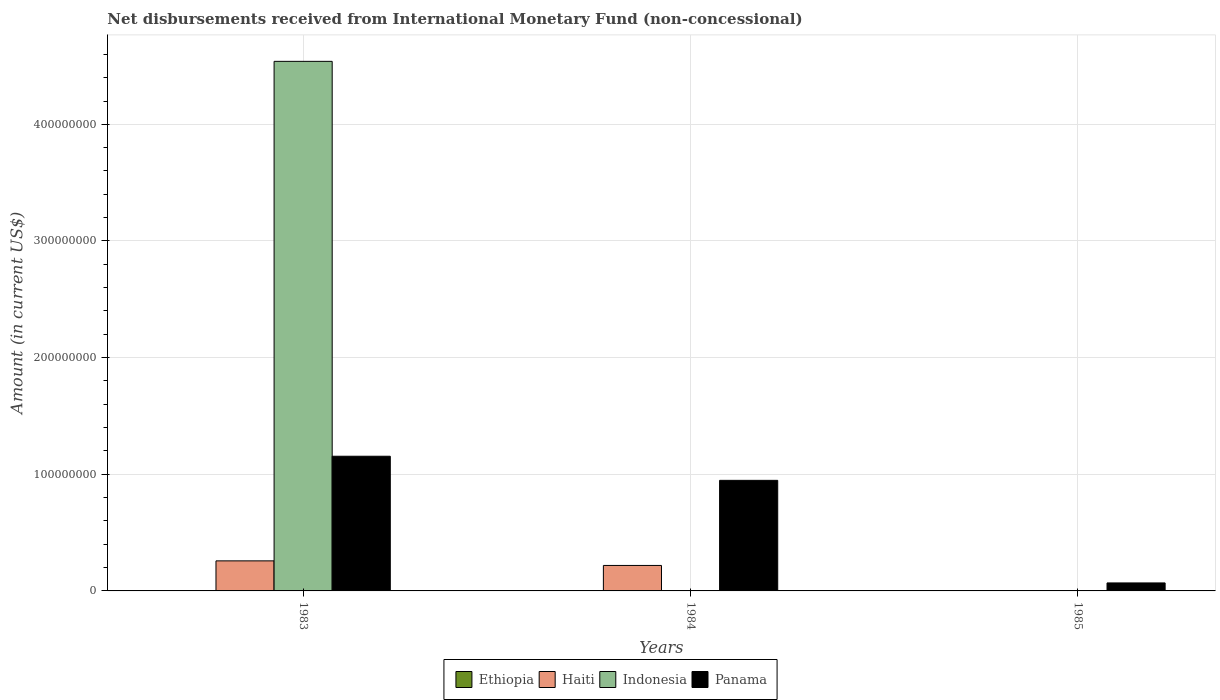What is the label of the 1st group of bars from the left?
Provide a short and direct response. 1983. In how many cases, is the number of bars for a given year not equal to the number of legend labels?
Make the answer very short. 3. What is the amount of disbursements received from International Monetary Fund in Panama in 1985?
Your answer should be very brief. 6.85e+06. Across all years, what is the maximum amount of disbursements received from International Monetary Fund in Indonesia?
Make the answer very short. 4.54e+08. Across all years, what is the minimum amount of disbursements received from International Monetary Fund in Panama?
Keep it short and to the point. 6.85e+06. In which year was the amount of disbursements received from International Monetary Fund in Haiti maximum?
Provide a short and direct response. 1983. What is the total amount of disbursements received from International Monetary Fund in Indonesia in the graph?
Provide a short and direct response. 4.54e+08. What is the difference between the amount of disbursements received from International Monetary Fund in Panama in 1983 and that in 1984?
Offer a very short reply. 2.07e+07. What is the difference between the amount of disbursements received from International Monetary Fund in Panama in 1983 and the amount of disbursements received from International Monetary Fund in Haiti in 1985?
Give a very brief answer. 1.15e+08. What is the average amount of disbursements received from International Monetary Fund in Haiti per year?
Provide a short and direct response. 1.59e+07. In the year 1983, what is the difference between the amount of disbursements received from International Monetary Fund in Panama and amount of disbursements received from International Monetary Fund in Indonesia?
Your response must be concise. -3.39e+08. Is the amount of disbursements received from International Monetary Fund in Panama in 1983 less than that in 1985?
Your response must be concise. No. What is the difference between the highest and the lowest amount of disbursements received from International Monetary Fund in Haiti?
Give a very brief answer. 2.58e+07. Is it the case that in every year, the sum of the amount of disbursements received from International Monetary Fund in Indonesia and amount of disbursements received from International Monetary Fund in Ethiopia is greater than the sum of amount of disbursements received from International Monetary Fund in Haiti and amount of disbursements received from International Monetary Fund in Panama?
Offer a terse response. No. Is it the case that in every year, the sum of the amount of disbursements received from International Monetary Fund in Panama and amount of disbursements received from International Monetary Fund in Haiti is greater than the amount of disbursements received from International Monetary Fund in Ethiopia?
Keep it short and to the point. Yes. How many bars are there?
Offer a very short reply. 6. Are all the bars in the graph horizontal?
Ensure brevity in your answer.  No. What is the difference between two consecutive major ticks on the Y-axis?
Give a very brief answer. 1.00e+08. Are the values on the major ticks of Y-axis written in scientific E-notation?
Give a very brief answer. No. Does the graph contain any zero values?
Provide a short and direct response. Yes. Where does the legend appear in the graph?
Provide a succinct answer. Bottom center. What is the title of the graph?
Keep it short and to the point. Net disbursements received from International Monetary Fund (non-concessional). What is the label or title of the X-axis?
Provide a succinct answer. Years. What is the Amount (in current US$) in Ethiopia in 1983?
Keep it short and to the point. 0. What is the Amount (in current US$) of Haiti in 1983?
Provide a short and direct response. 2.58e+07. What is the Amount (in current US$) in Indonesia in 1983?
Your response must be concise. 4.54e+08. What is the Amount (in current US$) of Panama in 1983?
Ensure brevity in your answer.  1.15e+08. What is the Amount (in current US$) of Haiti in 1984?
Your response must be concise. 2.18e+07. What is the Amount (in current US$) of Indonesia in 1984?
Your response must be concise. 0. What is the Amount (in current US$) of Panama in 1984?
Offer a terse response. 9.48e+07. What is the Amount (in current US$) of Ethiopia in 1985?
Provide a short and direct response. 0. What is the Amount (in current US$) in Haiti in 1985?
Provide a short and direct response. 0. What is the Amount (in current US$) in Indonesia in 1985?
Offer a terse response. 0. What is the Amount (in current US$) of Panama in 1985?
Your answer should be very brief. 6.85e+06. Across all years, what is the maximum Amount (in current US$) of Haiti?
Ensure brevity in your answer.  2.58e+07. Across all years, what is the maximum Amount (in current US$) in Indonesia?
Your response must be concise. 4.54e+08. Across all years, what is the maximum Amount (in current US$) in Panama?
Ensure brevity in your answer.  1.15e+08. Across all years, what is the minimum Amount (in current US$) in Indonesia?
Your answer should be very brief. 0. Across all years, what is the minimum Amount (in current US$) of Panama?
Your response must be concise. 6.85e+06. What is the total Amount (in current US$) of Haiti in the graph?
Provide a short and direct response. 4.76e+07. What is the total Amount (in current US$) of Indonesia in the graph?
Keep it short and to the point. 4.54e+08. What is the total Amount (in current US$) in Panama in the graph?
Make the answer very short. 2.17e+08. What is the difference between the Amount (in current US$) in Haiti in 1983 and that in 1984?
Give a very brief answer. 3.93e+06. What is the difference between the Amount (in current US$) of Panama in 1983 and that in 1984?
Your response must be concise. 2.07e+07. What is the difference between the Amount (in current US$) of Panama in 1983 and that in 1985?
Your answer should be compact. 1.09e+08. What is the difference between the Amount (in current US$) in Panama in 1984 and that in 1985?
Your response must be concise. 8.79e+07. What is the difference between the Amount (in current US$) in Haiti in 1983 and the Amount (in current US$) in Panama in 1984?
Your answer should be compact. -6.90e+07. What is the difference between the Amount (in current US$) of Indonesia in 1983 and the Amount (in current US$) of Panama in 1984?
Offer a very short reply. 3.59e+08. What is the difference between the Amount (in current US$) of Haiti in 1983 and the Amount (in current US$) of Panama in 1985?
Provide a succinct answer. 1.89e+07. What is the difference between the Amount (in current US$) in Indonesia in 1983 and the Amount (in current US$) in Panama in 1985?
Your answer should be compact. 4.47e+08. What is the difference between the Amount (in current US$) of Haiti in 1984 and the Amount (in current US$) of Panama in 1985?
Make the answer very short. 1.50e+07. What is the average Amount (in current US$) of Haiti per year?
Make the answer very short. 1.59e+07. What is the average Amount (in current US$) of Indonesia per year?
Give a very brief answer. 1.51e+08. What is the average Amount (in current US$) in Panama per year?
Offer a terse response. 7.24e+07. In the year 1983, what is the difference between the Amount (in current US$) of Haiti and Amount (in current US$) of Indonesia?
Ensure brevity in your answer.  -4.28e+08. In the year 1983, what is the difference between the Amount (in current US$) in Haiti and Amount (in current US$) in Panama?
Your response must be concise. -8.97e+07. In the year 1983, what is the difference between the Amount (in current US$) in Indonesia and Amount (in current US$) in Panama?
Keep it short and to the point. 3.39e+08. In the year 1984, what is the difference between the Amount (in current US$) in Haiti and Amount (in current US$) in Panama?
Your answer should be very brief. -7.30e+07. What is the ratio of the Amount (in current US$) in Haiti in 1983 to that in 1984?
Offer a terse response. 1.18. What is the ratio of the Amount (in current US$) of Panama in 1983 to that in 1984?
Give a very brief answer. 1.22. What is the ratio of the Amount (in current US$) in Panama in 1983 to that in 1985?
Offer a very short reply. 16.86. What is the ratio of the Amount (in current US$) of Panama in 1984 to that in 1985?
Make the answer very short. 13.84. What is the difference between the highest and the second highest Amount (in current US$) of Panama?
Your answer should be compact. 2.07e+07. What is the difference between the highest and the lowest Amount (in current US$) in Haiti?
Offer a terse response. 2.58e+07. What is the difference between the highest and the lowest Amount (in current US$) of Indonesia?
Make the answer very short. 4.54e+08. What is the difference between the highest and the lowest Amount (in current US$) in Panama?
Your response must be concise. 1.09e+08. 